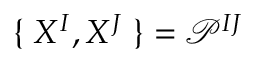Convert formula to latex. <formula><loc_0><loc_0><loc_500><loc_500>\{ \, X ^ { I } , X ^ { J } \, \} = \mathcal { P } ^ { I J }</formula> 